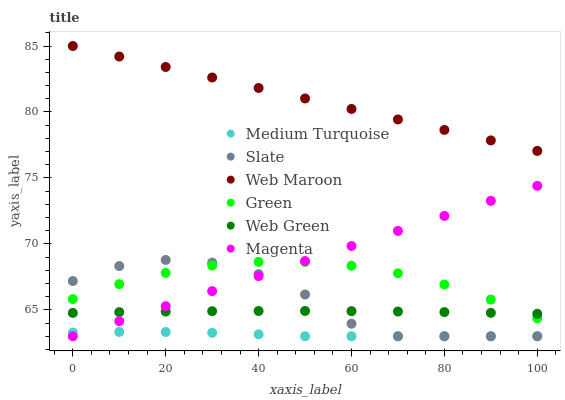Does Medium Turquoise have the minimum area under the curve?
Answer yes or no. Yes. Does Web Maroon have the maximum area under the curve?
Answer yes or no. Yes. Does Web Green have the minimum area under the curve?
Answer yes or no. No. Does Web Green have the maximum area under the curve?
Answer yes or no. No. Is Web Maroon the smoothest?
Answer yes or no. Yes. Is Slate the roughest?
Answer yes or no. Yes. Is Web Green the smoothest?
Answer yes or no. No. Is Web Green the roughest?
Answer yes or no. No. Does Slate have the lowest value?
Answer yes or no. Yes. Does Web Green have the lowest value?
Answer yes or no. No. Does Web Maroon have the highest value?
Answer yes or no. Yes. Does Web Green have the highest value?
Answer yes or no. No. Is Medium Turquoise less than Web Green?
Answer yes or no. Yes. Is Green greater than Medium Turquoise?
Answer yes or no. Yes. Does Web Green intersect Slate?
Answer yes or no. Yes. Is Web Green less than Slate?
Answer yes or no. No. Is Web Green greater than Slate?
Answer yes or no. No. Does Medium Turquoise intersect Web Green?
Answer yes or no. No. 